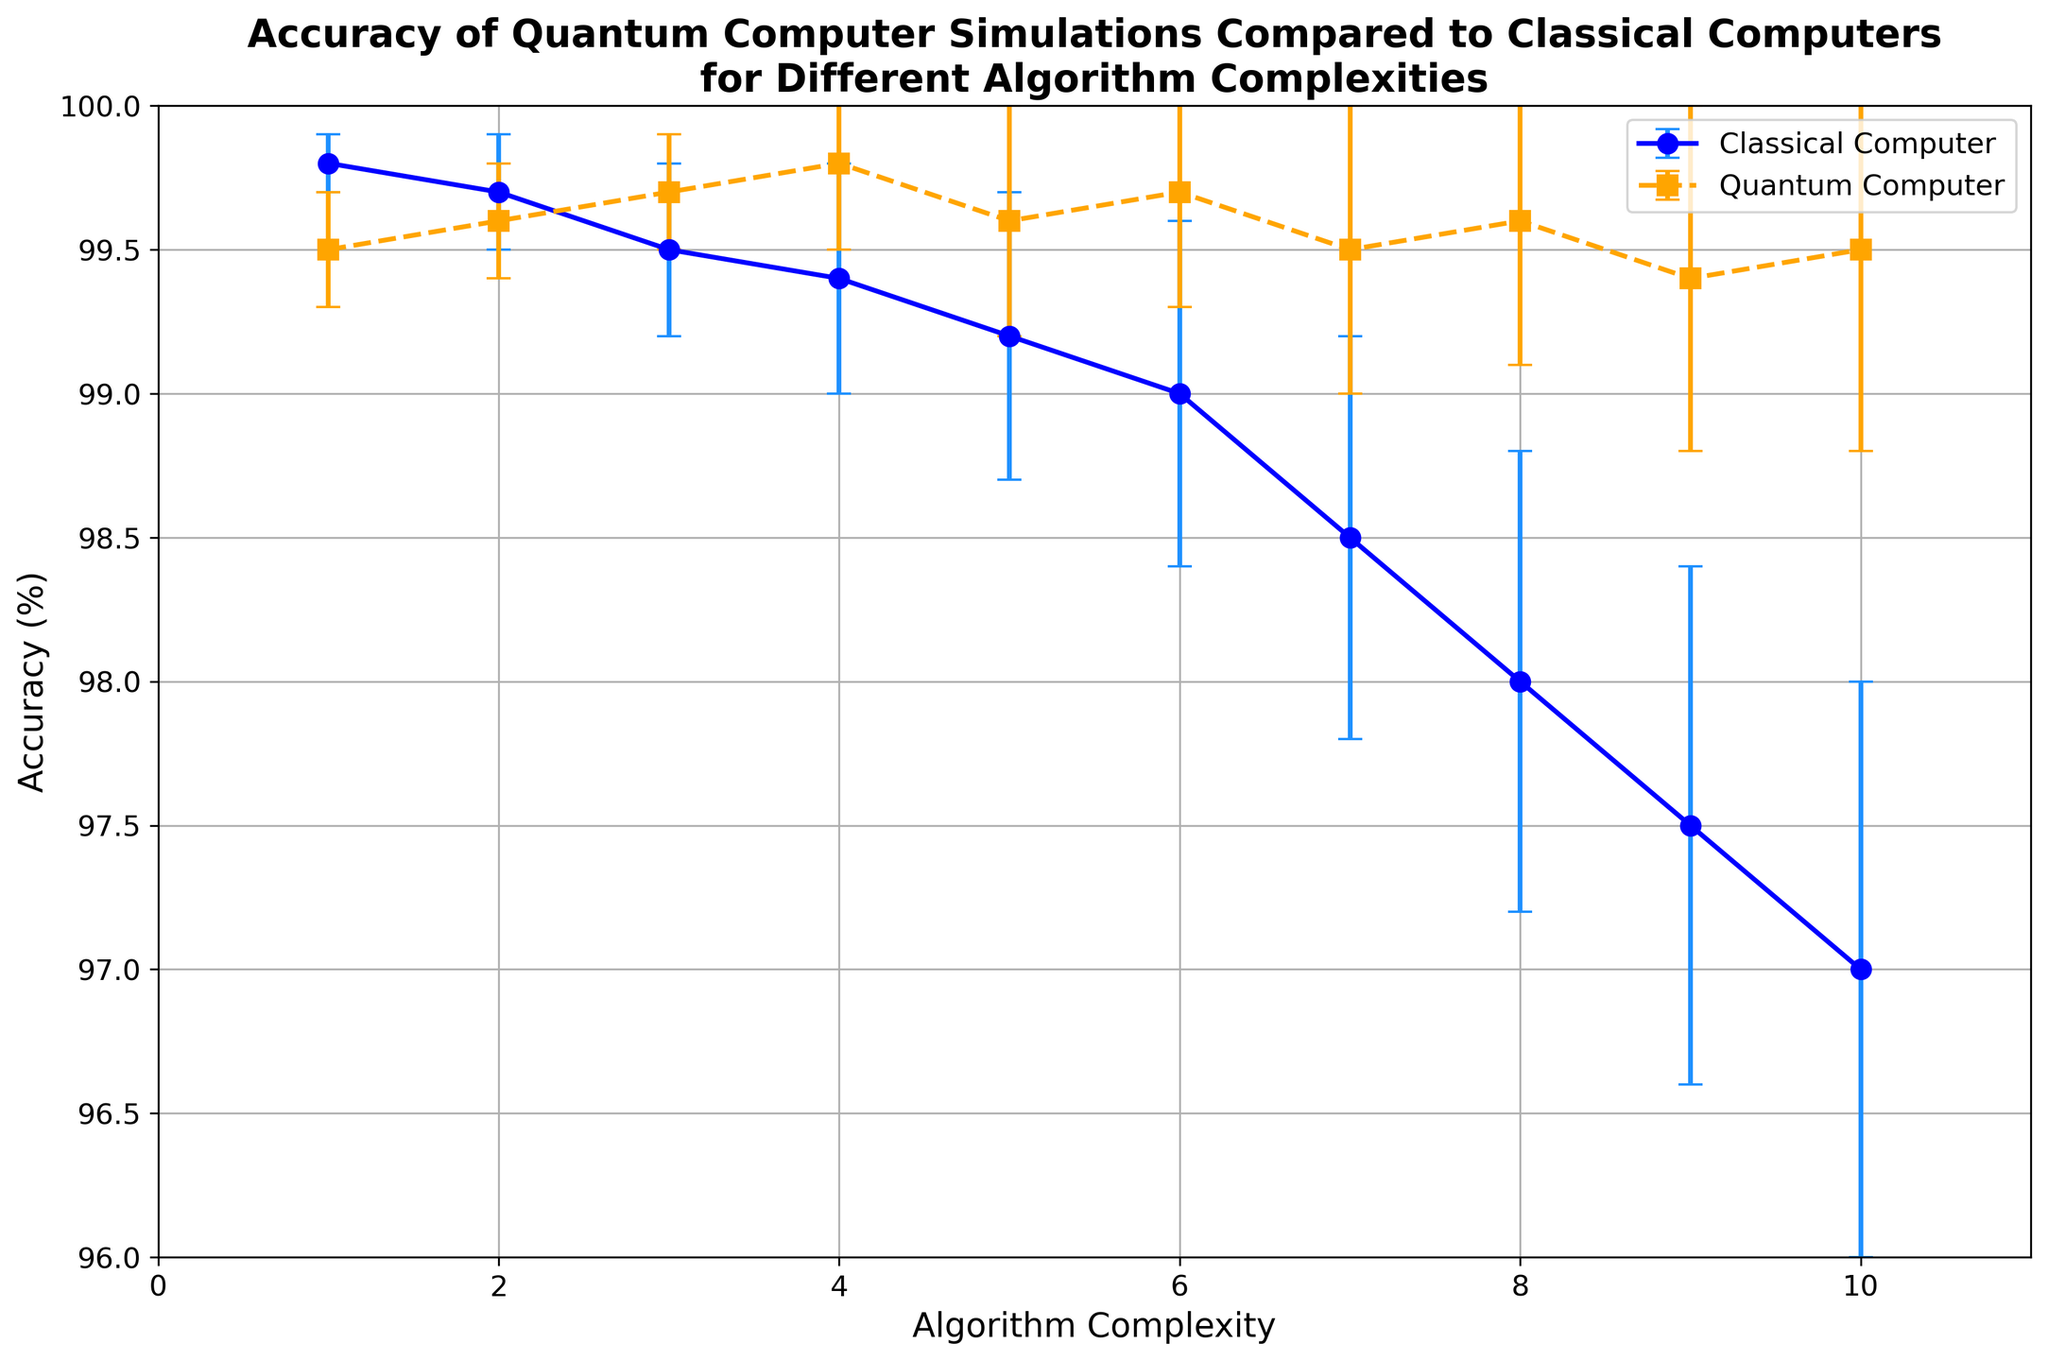What is the accuracy difference between classical and quantum computers at algorithm complexity 5? At algorithm complexity 5, the accuracy of the classical computer is 99.2% and the accuracy of the quantum computer is 99.6%. The difference can be calculated as 99.6% - 99.2% = 0.4%.
Answer: 0.4% At which algorithm complexity does the quantum computer first outperform the classical computer in terms of accuracy? By comparing accuracy values, we see that the quantum computer first has a higher accuracy (99.7%) than the classical computer (99.5%) at algorithm complexity 3.
Answer: 3 What is the average accuracy of the quantum computer for algorithm complexities 4 to 6? First, find the accuracy values for complexities 4, 5, and 6 which are 99.8%, 99.6%, and 99.7% respectively. Sum these values and divide by the number of values: (99.8 + 99.6 + 99.7) / 3 = 99.7%.
Answer: 99.7% Which computer type shows a larger variation in accuracy as measured by the error bars? The error bars for the classical computer (ranging from 0.1 to 1.0) are generally larger and more variable than those for the quantum computer (ranging from 0.2 to 0.7). Thus, the classical computer shows a larger variation.
Answer: Classical computer What trend can be observed in the accuracy of the classical computer as algorithm complexity increases? The accuracy of the classical computer shows a decreasing trend as the algorithm complexity increases from around 99.8% at complexity 1 to about 97.0% at complexity 10.
Answer: Decreasing trend Is there any point at which the accuracies of the quantum and classical computers are equal? If so, what is the algorithm complexity at that point? By examining the accuracy values, there is no point where the accuracies of the quantum and classical computers are exactly the same at any algorithm complexity level.
Answer: No What is the error range for the quantum computer's accuracy at algorithm complexity 7? At algorithm complexity 7, the accuracy of the quantum computer is 99.5% with an error of 0.5%. So, the range is 99.5% ± 0.5%, which means the range is from 99.0% to 100.0%.
Answer: 99.0% to 100.0% Which algorithm complexity shows the highest accuracy for quantum computers, and what is that accuracy? By checking each point, the highest accuracy for quantum computers is at algorithm complexity 4, with an accuracy of 99.8%.
Answer: 4, 99.8% 